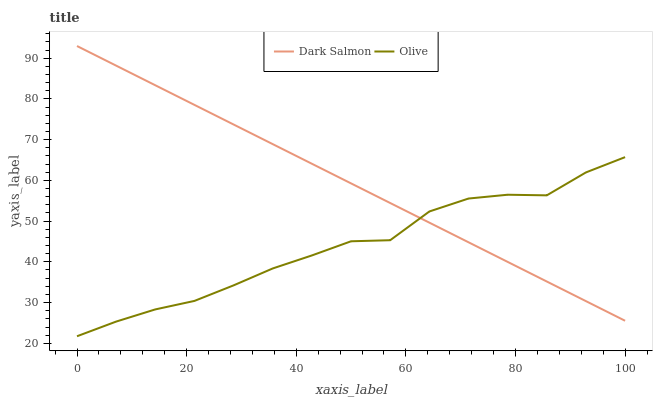Does Olive have the minimum area under the curve?
Answer yes or no. Yes. Does Dark Salmon have the maximum area under the curve?
Answer yes or no. Yes. Does Dark Salmon have the minimum area under the curve?
Answer yes or no. No. Is Dark Salmon the smoothest?
Answer yes or no. Yes. Is Olive the roughest?
Answer yes or no. Yes. Is Dark Salmon the roughest?
Answer yes or no. No. Does Olive have the lowest value?
Answer yes or no. Yes. Does Dark Salmon have the lowest value?
Answer yes or no. No. Does Dark Salmon have the highest value?
Answer yes or no. Yes. Does Olive intersect Dark Salmon?
Answer yes or no. Yes. Is Olive less than Dark Salmon?
Answer yes or no. No. Is Olive greater than Dark Salmon?
Answer yes or no. No. 